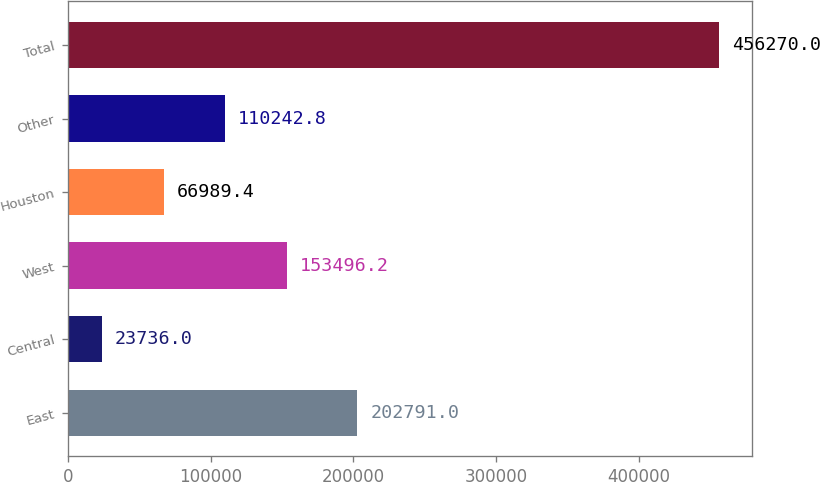Convert chart. <chart><loc_0><loc_0><loc_500><loc_500><bar_chart><fcel>East<fcel>Central<fcel>West<fcel>Houston<fcel>Other<fcel>Total<nl><fcel>202791<fcel>23736<fcel>153496<fcel>66989.4<fcel>110243<fcel>456270<nl></chart> 